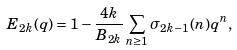<formula> <loc_0><loc_0><loc_500><loc_500>E _ { 2 k } ( q ) = 1 - \frac { 4 k } { B _ { 2 k } } \sum _ { n \geq 1 } \sigma _ { 2 k - 1 } ( n ) q ^ { n } ,</formula> 